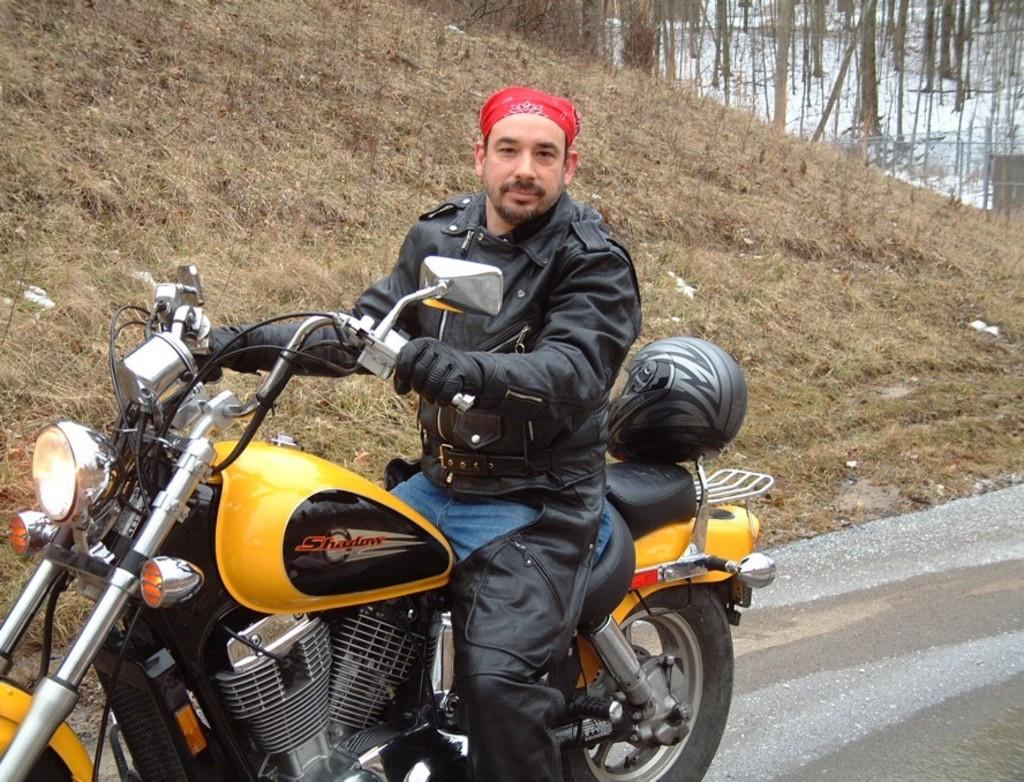What is the man wearing in the image? The man is wearing a black jacket. What is the man doing with the motorbike? The man is holding the handle of a motorbike and sitting on it. What is present on the motorbike? There is a helmet on the motorbike. What can be seen in the background of the image? There are trees in the distance. How many sheep are visible in the image? There are no sheep present in the image. What color is the hydrant next to the man? There is no hydrant present in the image. 